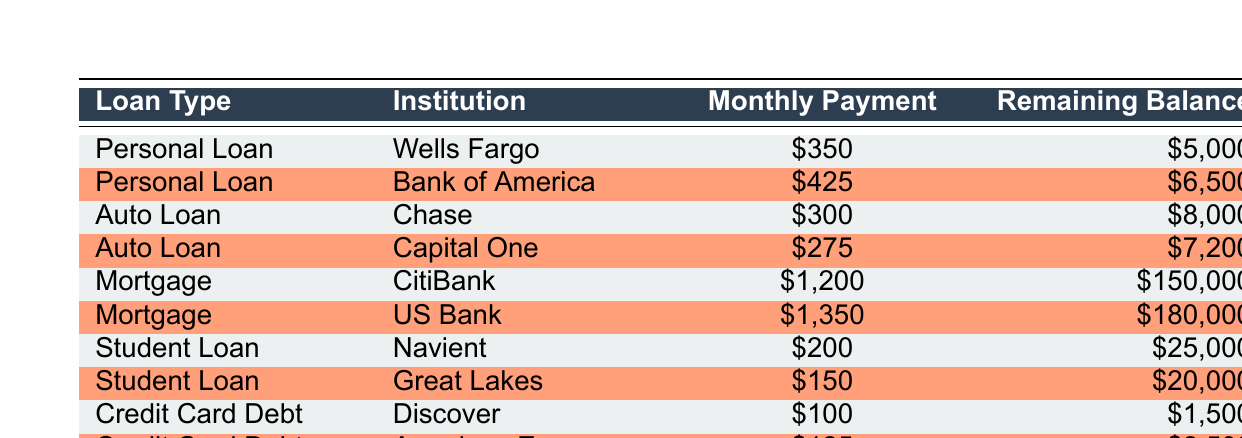What is the monthly payment for the personal loan from Bank of America? In the table, I can directly look under the “Personal Loan” section, where it states the institution is “Bank of America” and lists the monthly payment as $425. Therefore, the answer is the amount listed beside that institution.
Answer: 425 Which loan type has the highest remaining balance? To find this, I will look through all remaining balances of the loans listed. The highest remaining balance is associated with the mortgage from US Bank, which is $180,000. I compare all the balances and find this to be the largest.
Answer: 180000 What is the total monthly payment for all auto loans? To get the total monthly payment for all auto loans, I identify the monthly payments for Chase ($300) and Capital One ($275). I will sum these amounts: 300 + 275 = 575. Thus, the total amount paid monthly for auto loans is the result of this addition.
Answer: 575 Is the remaining balance for the Discover credit card debt less than $2,000? Checking the table reveals that the remaining balance for the Discover credit card debt is $1,500. Since $1,500 is indeed less than $2,000, the answer is true.
Answer: Yes What is the average monthly payment for personal loans? For personal loans, I take the monthly payments from Wells Fargo ($350) and Bank of America ($425). The average is calculated by first adding these amounts: 350 + 425 = 775. Then, I divide by the number of loans (2), resulting in an average of 775 / 2 = 387.5. Thus, the average monthly payment for personal loans is determined.
Answer: 387.5 Which institution has the lowest remaining balance across all loans? I need to compare all remaining balances listed in the table: $5,000 for Wells Fargo, $6,500 for Bank of America, $8,000 for Chase, $7,200 for Capital One, $150,000 for CitiBank, $180,000 for US Bank, $25,000 for Navient, $20,000 for Great Lakes, $1,500 for Discover, and $2,500 for American Express. The lowest amount is $1,500, associated with Discover. Therefore, the institution with the lowest remaining balance is evident from the comparisons.
Answer: Discover How much higher is the remaining balance for the student loan from Navient compared to the credit card debt from Discover? I check the remaining balance for each loan type. The balance for the Navient student loan is $25,000, while the Discover credit card debt is $1,500. To find the difference, I perform the subtraction: 25000 - 1500 = 23500. This shows how much higher the student loan balance is compared to the credit card debt.
Answer: 23500 Are there more types of loans with monthly payments above $400 than below? The loan types with monthly payments above $400 include the personal loan from Bank of America ($425), the mortgages (CitiBank $1,200 and US Bank $1,350), and the rest are below. So, there are three loans above $400 (two mortgages and one personal) and four loans below ($350 from Wells Fargo, $300 from Chase, $275 from Capital One, $200 from Navient, $150 from Great Lakes, $100 from Discover, $125 from American Express). Thus, the statement is false.
Answer: No 